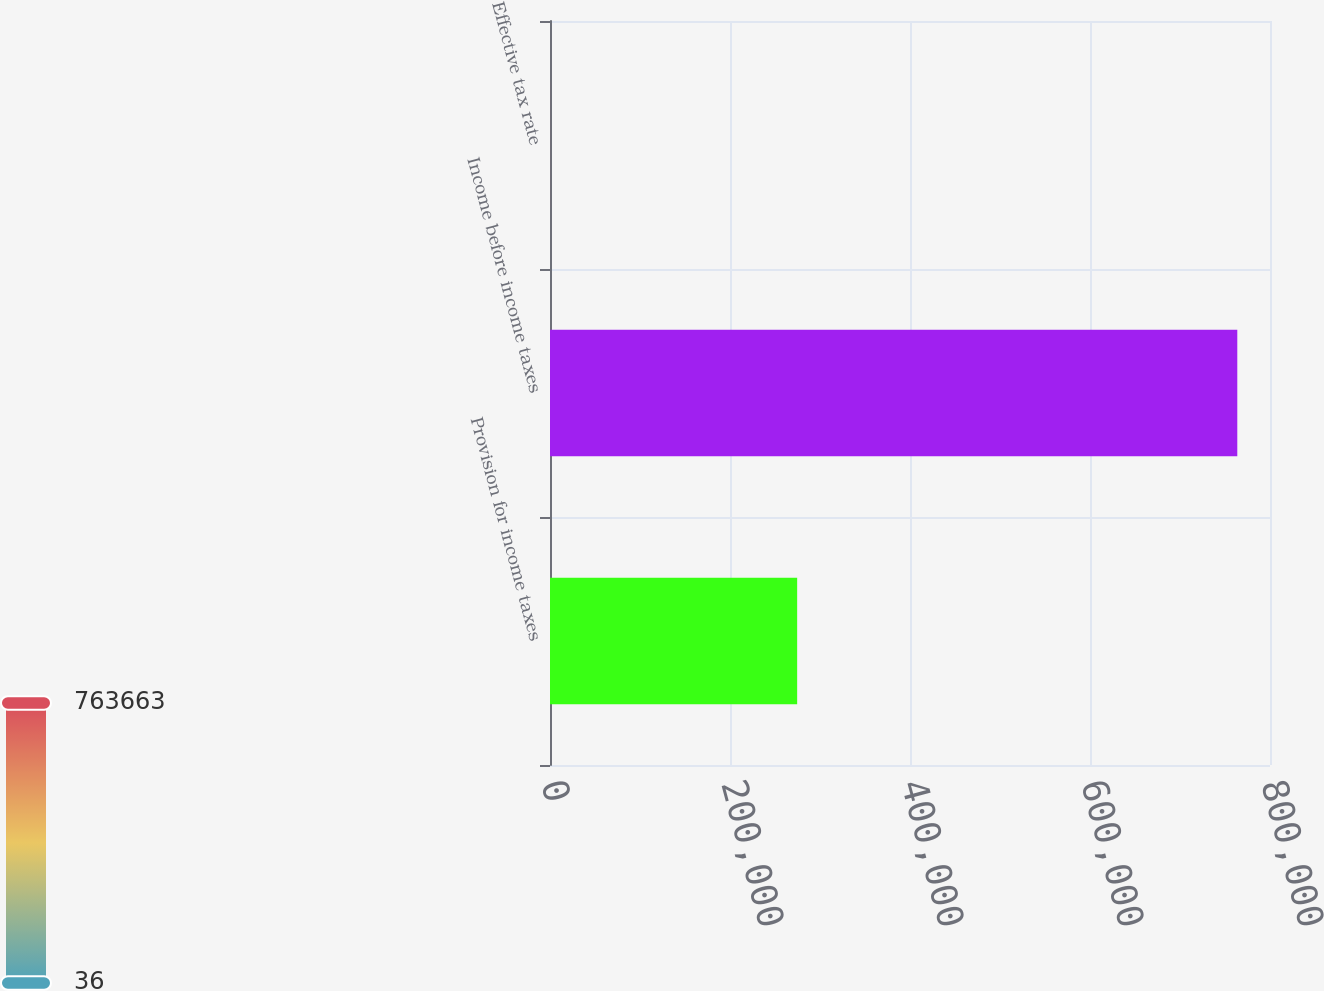<chart> <loc_0><loc_0><loc_500><loc_500><bar_chart><fcel>Provision for income taxes<fcel>Income before income taxes<fcel>Effective tax rate<nl><fcel>274616<fcel>763663<fcel>36<nl></chart> 